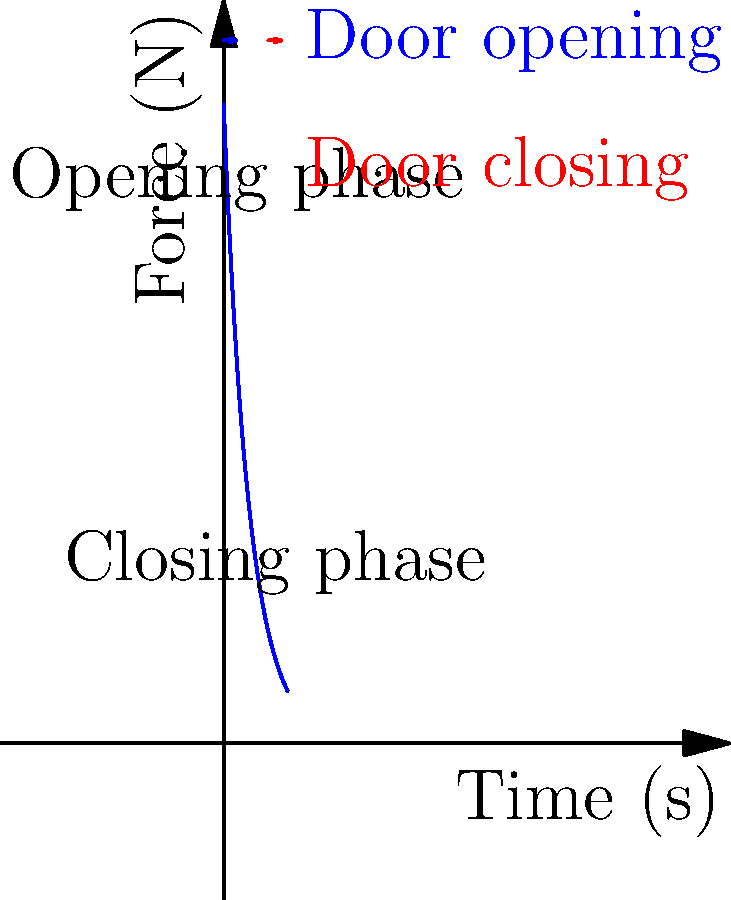As you consider implementing automatic sliding doors in your potential brick-and-mortar showrooms, you're presented with the following force-time graph representing the operation of such a door. The blue curve shows the applied force by the door motor over time. What physical principle explains why the force decreases exponentially during the opening phase, and how might this impact the door's energy efficiency? To answer this question, let's break down the physical principles at play:

1. Initial force: The door motor applies a large initial force to overcome static friction and inertia of the door.

2. Exponential decrease: The force decreases exponentially due to several factors:
   a) Reduction in friction: As the door gains momentum, rolling friction replaces static friction.
   b) Conservation of energy: Some of the initial energy is converted to kinetic energy of the door.
   c) Momentum: Once moving, less force is needed to maintain motion.

3. Energy efficiency:
   a) The exponential decrease allows for efficient use of energy. High initial force quickly gets the door moving.
   b) Reduced force during motion conserves energy while maintaining speed.
   c) This pattern minimizes overall energy consumption compared to constant force application.

4. Closing phase:
   The graph shows a smaller force for closing, likely due to gravity assistance and the door's momentum.

5. Relevance to e-commerce showrooms:
   Understanding this principle helps in selecting energy-efficient door systems, potentially reducing operational costs in physical store locations.

The physical principle explaining the exponential decrease is a combination of Newton's laws of motion and the principle of conservation of energy. As the door gains momentum, less force is required to maintain its motion, resulting in more efficient energy use over the door's operation cycle.
Answer: Newton's laws and energy conservation; exponential force decrease improves energy efficiency. 